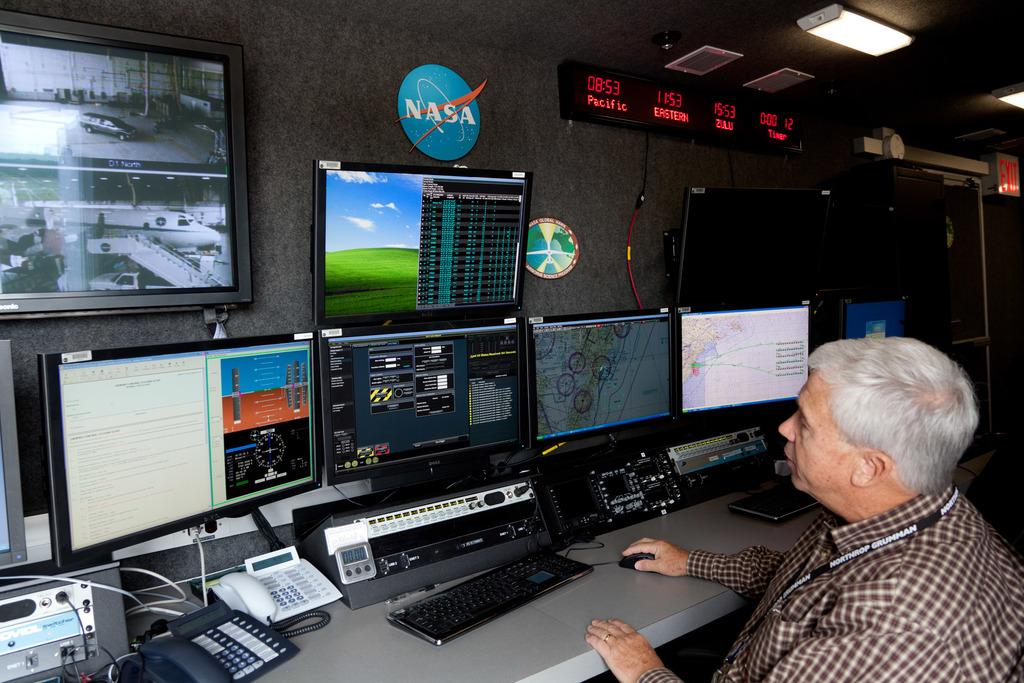<image>
Give a short and clear explanation of the subsequent image. A man sitting in front of a bank of computer monitors with a NASA sign on the wall above them. 